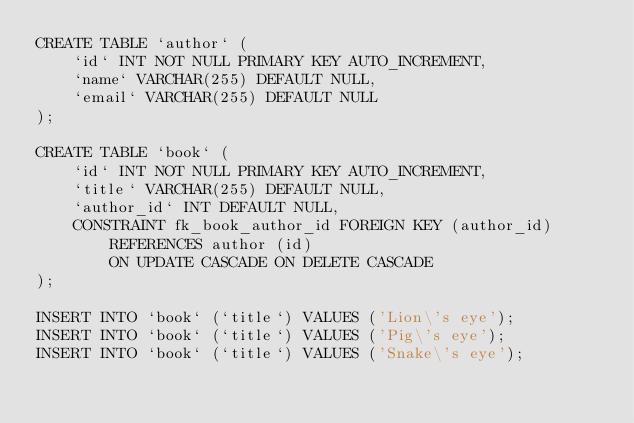Convert code to text. <code><loc_0><loc_0><loc_500><loc_500><_SQL_>CREATE TABLE `author` (
    `id` INT NOT NULL PRIMARY KEY AUTO_INCREMENT,
    `name` VARCHAR(255) DEFAULT NULL,
    `email` VARCHAR(255) DEFAULT NULL
);

CREATE TABLE `book` (
    `id` INT NOT NULL PRIMARY KEY AUTO_INCREMENT,
    `title` VARCHAR(255) DEFAULT NULL,
    `author_id` INT DEFAULT NULL,
    CONSTRAINT fk_book_author_id FOREIGN KEY (author_id)
        REFERENCES author (id)
        ON UPDATE CASCADE ON DELETE CASCADE
);

INSERT INTO `book` (`title`) VALUES ('Lion\'s eye');
INSERT INTO `book` (`title`) VALUES ('Pig\'s eye');
INSERT INTO `book` (`title`) VALUES ('Snake\'s eye');</code> 